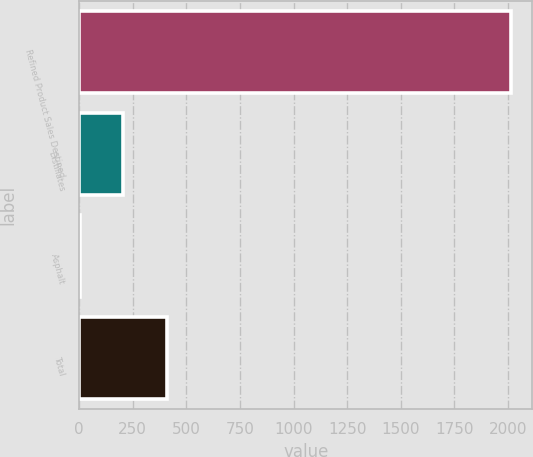Convert chart to OTSL. <chart><loc_0><loc_0><loc_500><loc_500><bar_chart><fcel>Refined Product Sales Destined<fcel>Distillates<fcel>Asphalt<fcel>Total<nl><fcel>2013<fcel>206.7<fcel>6<fcel>407.4<nl></chart> 